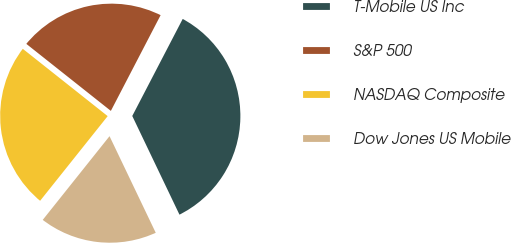Convert chart. <chart><loc_0><loc_0><loc_500><loc_500><pie_chart><fcel>T-Mobile US Inc<fcel>S&P 500<fcel>NASDAQ Composite<fcel>Dow Jones US Mobile<nl><fcel>35.27%<fcel>21.96%<fcel>24.95%<fcel>17.82%<nl></chart> 